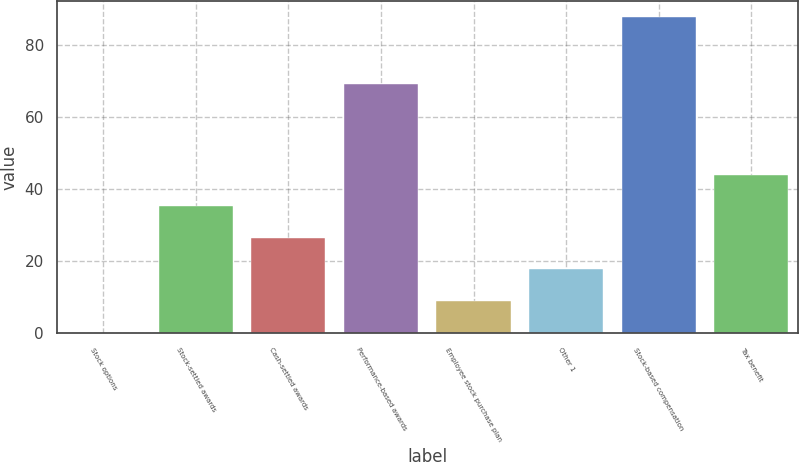Convert chart to OTSL. <chart><loc_0><loc_0><loc_500><loc_500><bar_chart><fcel>Stock options<fcel>Stock-settled awards<fcel>Cash-settled awards<fcel>Performance-based awards<fcel>Employee stock purchase plan<fcel>Other 1<fcel>Stock-based compensation<fcel>Tax benefit<nl><fcel>0.2<fcel>35.32<fcel>26.54<fcel>69.4<fcel>8.98<fcel>17.76<fcel>88<fcel>44.1<nl></chart> 